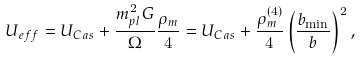<formula> <loc_0><loc_0><loc_500><loc_500>U _ { e f f } = U _ { C a s } + \frac { m _ { p l } ^ { 2 } G } { \Omega } \frac { \rho _ { m } } { 4 } = U _ { C a s } + \frac { \rho _ { m } ^ { ( 4 ) } } { 4 } \left ( \frac { b _ { \min } } { b } \right ) ^ { 2 } ,</formula> 